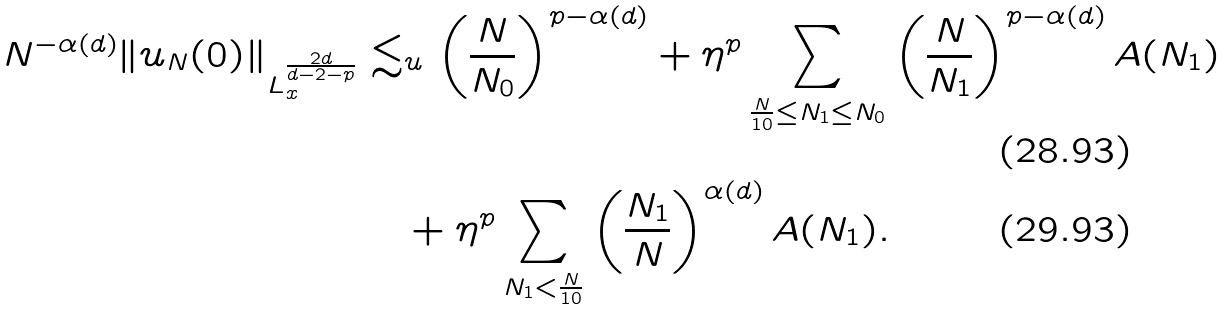Convert formula to latex. <formula><loc_0><loc_0><loc_500><loc_500>N ^ { - \alpha ( d ) } \| u _ { N } ( 0 ) \| _ { L _ { x } ^ { \frac { 2 d } { d - 2 - p } } } & \lesssim _ { u } \left ( \frac { N } { N _ { 0 } } \right ) ^ { p - \alpha ( d ) } + \eta ^ { p } \sum _ { \frac { N } { 1 0 } \leq N _ { 1 } \leq N _ { 0 } } \left ( \frac { N } { N _ { 1 } } \right ) ^ { p - \alpha ( d ) } A ( N _ { 1 } ) \\ & \quad + \eta ^ { p } \sum _ { N _ { 1 } < \frac { N } { 1 0 } } \left ( \frac { N _ { 1 } } { N } \right ) ^ { \alpha ( d ) } A ( N _ { 1 } ) .</formula> 